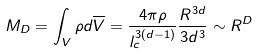Convert formula to latex. <formula><loc_0><loc_0><loc_500><loc_500>M _ { D } = \int _ { V } \rho d \overline { V } = \frac { 4 \pi \rho } { l _ { c } ^ { 3 ( d - 1 ) } } \frac { R ^ { 3 d } } { 3 d ^ { 3 } } \sim R ^ { D }</formula> 